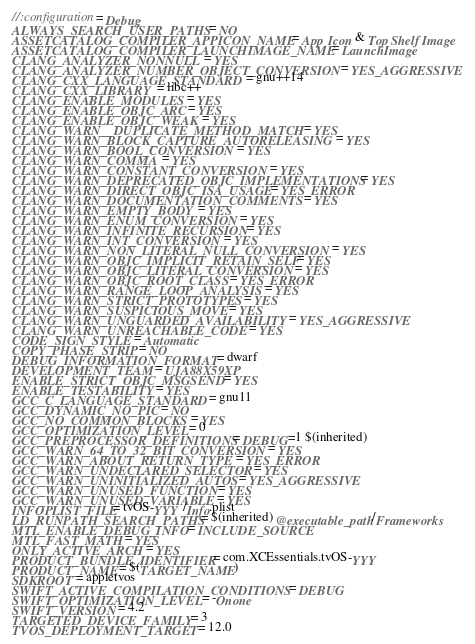<code> <loc_0><loc_0><loc_500><loc_500><_Ruby_>//:configuration = Debug
ALWAYS_SEARCH_USER_PATHS = NO
ASSETCATALOG_COMPILER_APPICON_NAME = App Icon & Top Shelf Image
ASSETCATALOG_COMPILER_LAUNCHIMAGE_NAME = LaunchImage
CLANG_ANALYZER_NONNULL = YES
CLANG_ANALYZER_NUMBER_OBJECT_CONVERSION = YES_AGGRESSIVE
CLANG_CXX_LANGUAGE_STANDARD = gnu++14
CLANG_CXX_LIBRARY = libc++
CLANG_ENABLE_MODULES = YES
CLANG_ENABLE_OBJC_ARC = YES
CLANG_ENABLE_OBJC_WEAK = YES
CLANG_WARN__DUPLICATE_METHOD_MATCH = YES
CLANG_WARN_BLOCK_CAPTURE_AUTORELEASING = YES
CLANG_WARN_BOOL_CONVERSION = YES
CLANG_WARN_COMMA = YES
CLANG_WARN_CONSTANT_CONVERSION = YES
CLANG_WARN_DEPRECATED_OBJC_IMPLEMENTATIONS = YES
CLANG_WARN_DIRECT_OBJC_ISA_USAGE = YES_ERROR
CLANG_WARN_DOCUMENTATION_COMMENTS = YES
CLANG_WARN_EMPTY_BODY = YES
CLANG_WARN_ENUM_CONVERSION = YES
CLANG_WARN_INFINITE_RECURSION = YES
CLANG_WARN_INT_CONVERSION = YES
CLANG_WARN_NON_LITERAL_NULL_CONVERSION = YES
CLANG_WARN_OBJC_IMPLICIT_RETAIN_SELF = YES
CLANG_WARN_OBJC_LITERAL_CONVERSION = YES
CLANG_WARN_OBJC_ROOT_CLASS = YES_ERROR
CLANG_WARN_RANGE_LOOP_ANALYSIS = YES
CLANG_WARN_STRICT_PROTOTYPES = YES
CLANG_WARN_SUSPICIOUS_MOVE = YES
CLANG_WARN_UNGUARDED_AVAILABILITY = YES_AGGRESSIVE
CLANG_WARN_UNREACHABLE_CODE = YES
CODE_SIGN_STYLE = Automatic
COPY_PHASE_STRIP = NO
DEBUG_INFORMATION_FORMAT = dwarf
DEVELOPMENT_TEAM = UJA88X59XP
ENABLE_STRICT_OBJC_MSGSEND = YES
ENABLE_TESTABILITY = YES
GCC_C_LANGUAGE_STANDARD = gnu11
GCC_DYNAMIC_NO_PIC = NO
GCC_NO_COMMON_BLOCKS = YES
GCC_OPTIMIZATION_LEVEL = 0
GCC_PREPROCESSOR_DEFINITIONS = DEBUG=1 $(inherited)
GCC_WARN_64_TO_32_BIT_CONVERSION = YES
GCC_WARN_ABOUT_RETURN_TYPE = YES_ERROR
GCC_WARN_UNDECLARED_SELECTOR = YES
GCC_WARN_UNINITIALIZED_AUTOS = YES_AGGRESSIVE
GCC_WARN_UNUSED_FUNCTION = YES
GCC_WARN_UNUSED_VARIABLE = YES
INFOPLIST_FILE = tvOS-YYY/Info.plist
LD_RUNPATH_SEARCH_PATHS = $(inherited) @executable_path/Frameworks
MTL_ENABLE_DEBUG_INFO = INCLUDE_SOURCE
MTL_FAST_MATH = YES
ONLY_ACTIVE_ARCH = YES
PRODUCT_BUNDLE_IDENTIFIER = com.XCEssentials.tvOS-YYY
PRODUCT_NAME = $(TARGET_NAME)
SDKROOT = appletvos
SWIFT_ACTIVE_COMPILATION_CONDITIONS = DEBUG
SWIFT_OPTIMIZATION_LEVEL = -Onone
SWIFT_VERSION = 4.2
TARGETED_DEVICE_FAMILY = 3
TVOS_DEPLOYMENT_TARGET = 12.0
</code> 